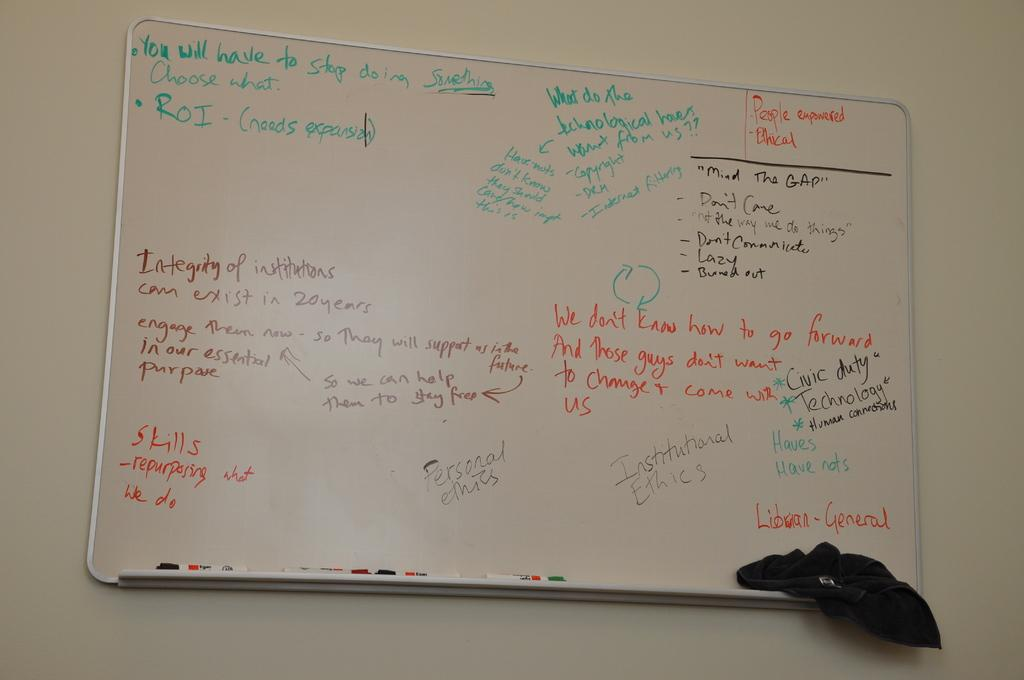<image>
Give a short and clear explanation of the subsequent image. A white board says "You will have to stop doing something" at the top. 